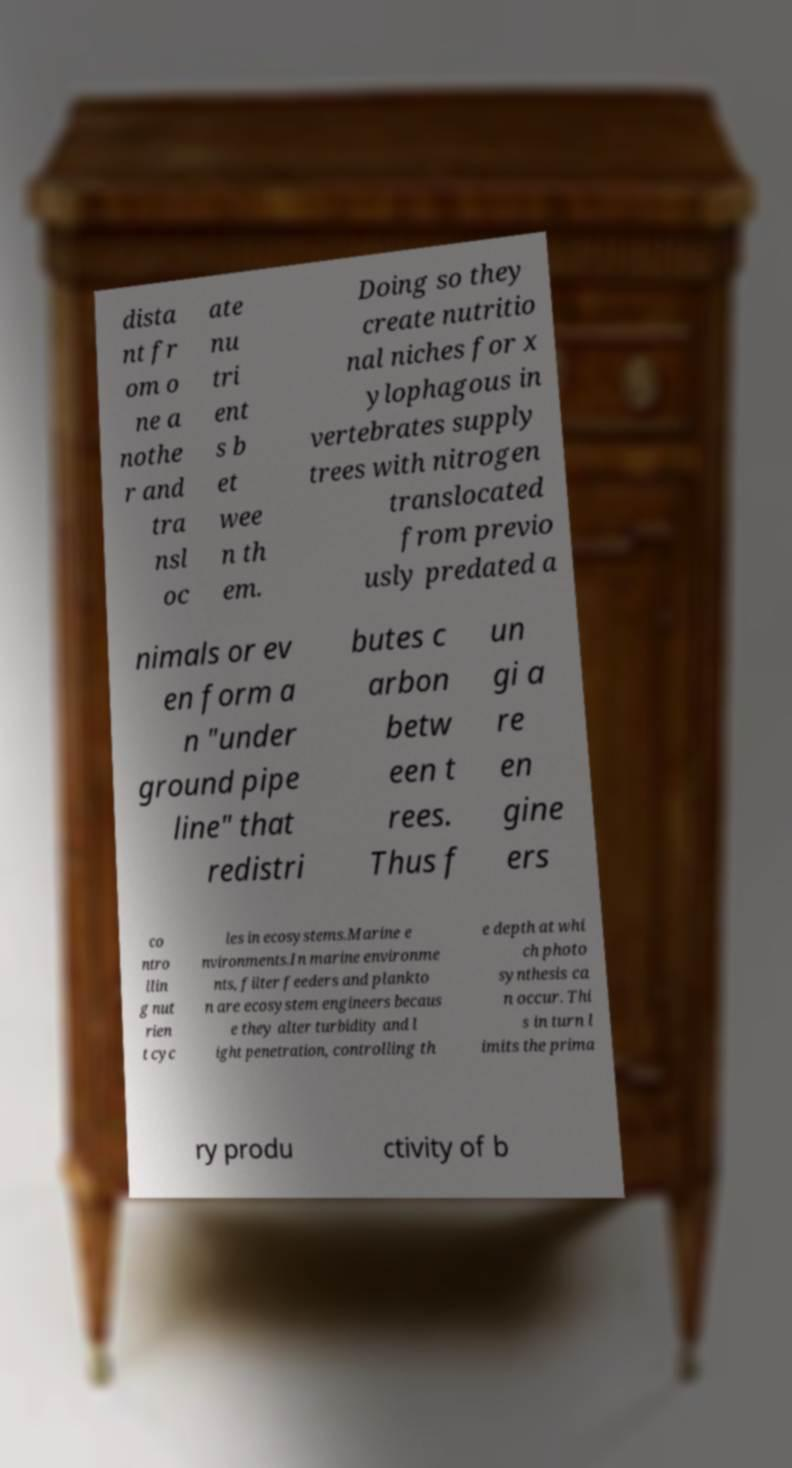Could you extract and type out the text from this image? dista nt fr om o ne a nothe r and tra nsl oc ate nu tri ent s b et wee n th em. Doing so they create nutritio nal niches for x ylophagous in vertebrates supply trees with nitrogen translocated from previo usly predated a nimals or ev en form a n "under ground pipe line" that redistri butes c arbon betw een t rees. Thus f un gi a re en gine ers co ntro llin g nut rien t cyc les in ecosystems.Marine e nvironments.In marine environme nts, filter feeders and plankto n are ecosystem engineers becaus e they alter turbidity and l ight penetration, controlling th e depth at whi ch photo synthesis ca n occur. Thi s in turn l imits the prima ry produ ctivity of b 